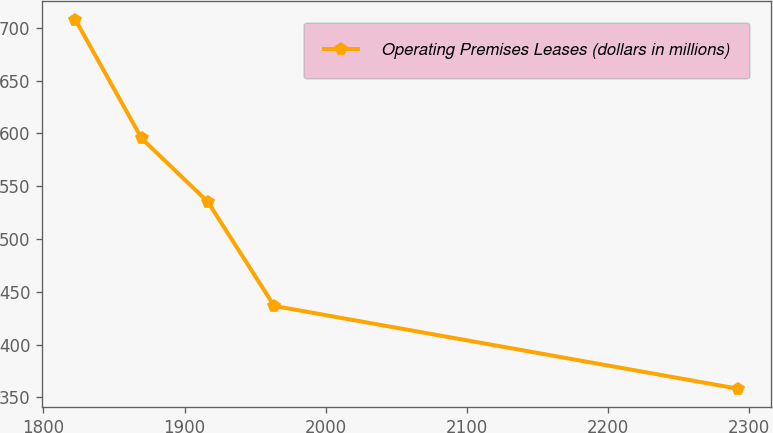<chart> <loc_0><loc_0><loc_500><loc_500><line_chart><ecel><fcel>Operating Premises Leases (dollars in millions)<nl><fcel>1822.63<fcel>707.77<nl><fcel>1869.58<fcel>595.34<nl><fcel>1916.53<fcel>535.16<nl><fcel>1963.48<fcel>436.6<nl><fcel>2292.15<fcel>358.17<nl></chart> 